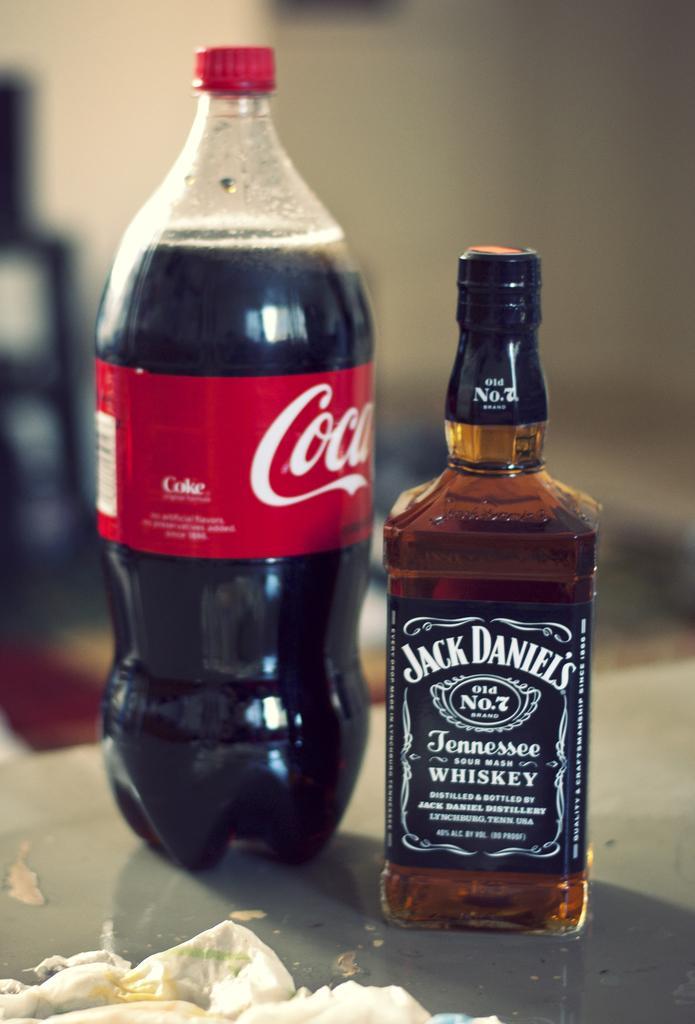In one or two sentences, can you explain what this image depicts? There is a coca cola bottle with red cap and a label on it. Also there is a another bottle with a label. Both are kept on table. On the table there are some items. 